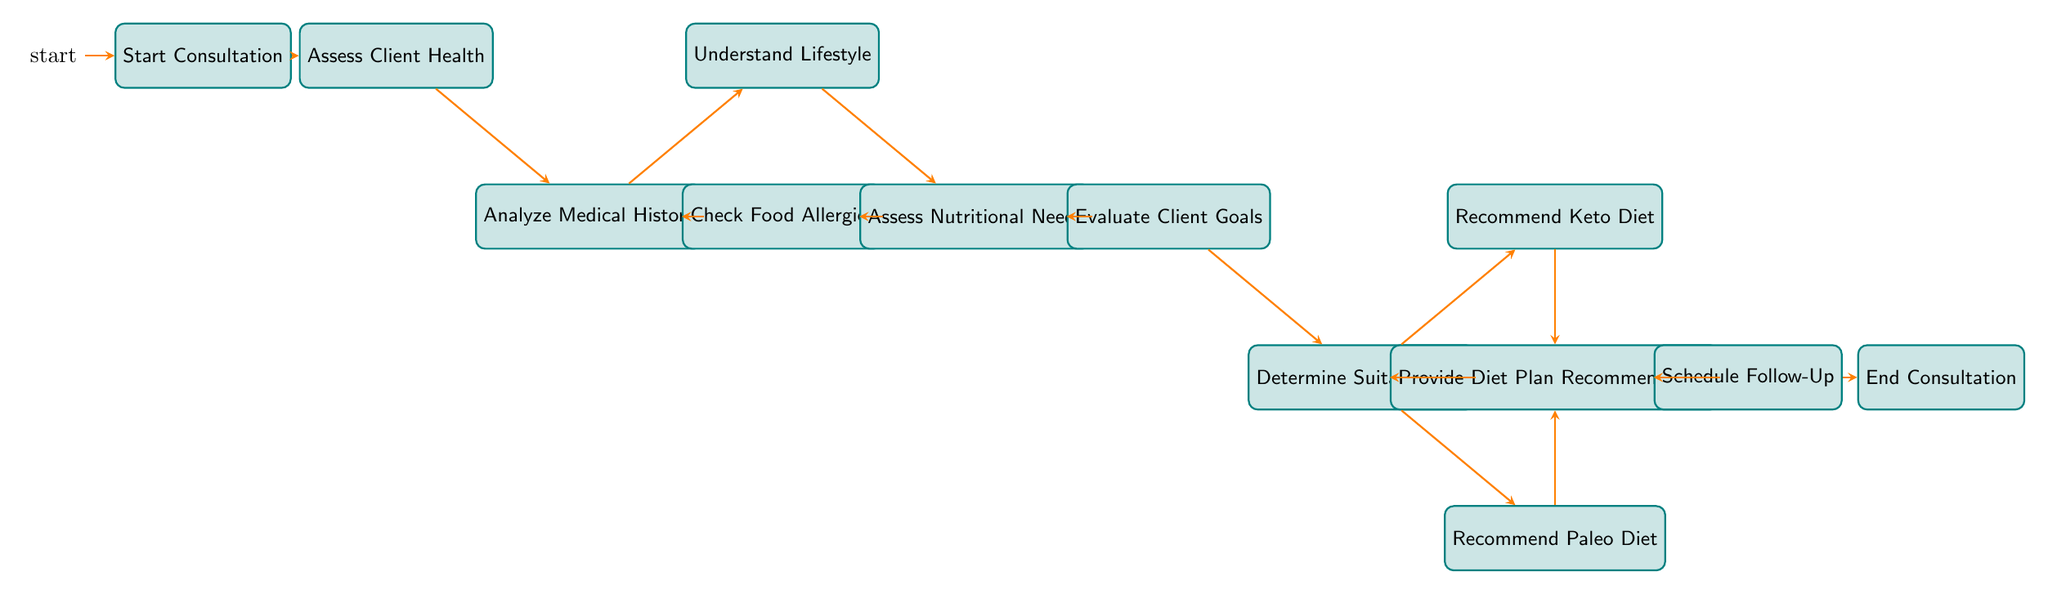What is the initial state of the consultation process? The initial state listed in the diagram is "Start Consultation." This is the first node in the flow of the client consultation workflow.
Answer: Start Consultation How many states are there in the process? By counting the unique states in the diagram, there are a total of 12 distinct states that clients will go through in the workflow.
Answer: 12 What are the two paths leading from the "Analyze Medical History" state? The paths leading from "Analyze Medical History" are "Check Food Allergies" and "Understand Lifestyle." Both transitions are valid actions from this state.
Answer: Check Food Allergies, Understand Lifestyle Which state follows "Assess Client Health"? After "Assess Client Health," the next state is "Analyze Medical History". This transition follows as the process continues to analyze the client's medical background.
Answer: Analyze Medical History What state does "Check Food Allergies" lead to? The "Check Food Allergies" state leads to "Assess Nutritional Needs." This indicates that once allergies are checked, the next step is to evaluate nutritional requirements.
Answer: Assess Nutritional Needs What are the three outcomes from "Determine Suitable Diet"? From "Determine Suitable Diet," the three possible transitions are "Provide Diet Plan Recommendation," "Recommend Keto Diet," and "Recommend Paleo Diet." These outcomes guide the consultation towards specific diet recommendations.
Answer: Provide Diet Plan Recommendation, Recommend Keto Diet, Recommend Paleo Diet Which state is reached if the decision is made to recommend a keto diet? If a keto diet is recommended, the next state reached is "Keto Diet Suggested." This indicates the consultation moves forward with this specific dietary recommendation.
Answer: Keto Diet Suggested What comes after "Provide Diet Plan Recommendation"? After "Provide Diet Plan Recommendation," the next state is "Schedule Follow-Up," indicating the next step in the process is to arrange a follow-up meeting after the diet has been suggested.
Answer: Schedule Follow-Up How does the workflow conclude? The workflow concludes with the "End Consultation" state, which is the final state in the process, indicating that all steps have been completed.
Answer: End Consultation 